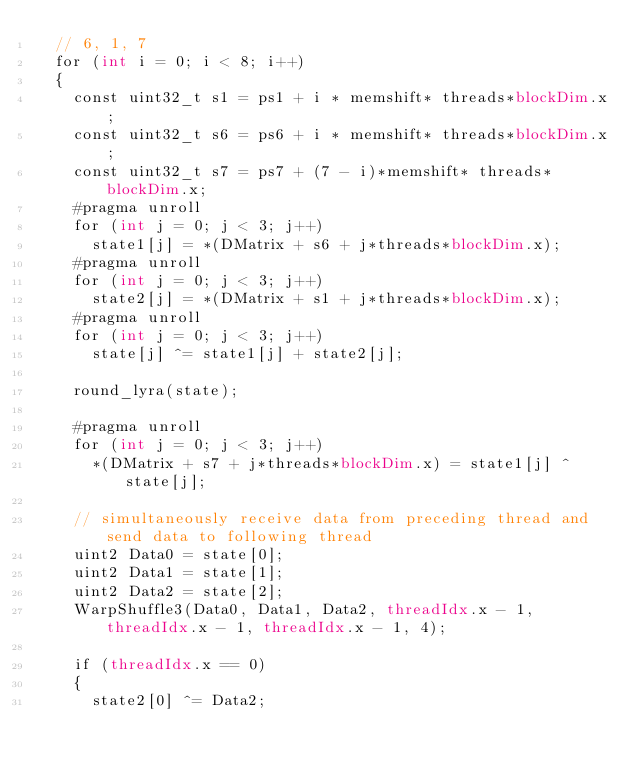Convert code to text. <code><loc_0><loc_0><loc_500><loc_500><_Cuda_>	// 6, 1, 7
	for (int i = 0; i < 8; i++)
	{
		const uint32_t s1 = ps1 + i * memshift* threads*blockDim.x;
		const uint32_t s6 = ps6 + i * memshift* threads*blockDim.x;
		const uint32_t s7 = ps7 + (7 - i)*memshift* threads*blockDim.x;
		#pragma unroll
		for (int j = 0; j < 3; j++)
			state1[j] = *(DMatrix + s6 + j*threads*blockDim.x);
		#pragma unroll
		for (int j = 0; j < 3; j++)
			state2[j] = *(DMatrix + s1 + j*threads*blockDim.x);
		#pragma unroll
		for (int j = 0; j < 3; j++)
			state[j] ^= state1[j] + state2[j];

		round_lyra(state);

		#pragma unroll
		for (int j = 0; j < 3; j++)
			*(DMatrix + s7 + j*threads*blockDim.x) = state1[j] ^ state[j];

		// simultaneously receive data from preceding thread and send data to following thread
		uint2 Data0 = state[0];
		uint2 Data1 = state[1];
		uint2 Data2 = state[2];
		WarpShuffle3(Data0, Data1, Data2, threadIdx.x - 1, threadIdx.x - 1, threadIdx.x - 1, 4);

		if (threadIdx.x == 0)
		{
			state2[0] ^= Data2;</code> 